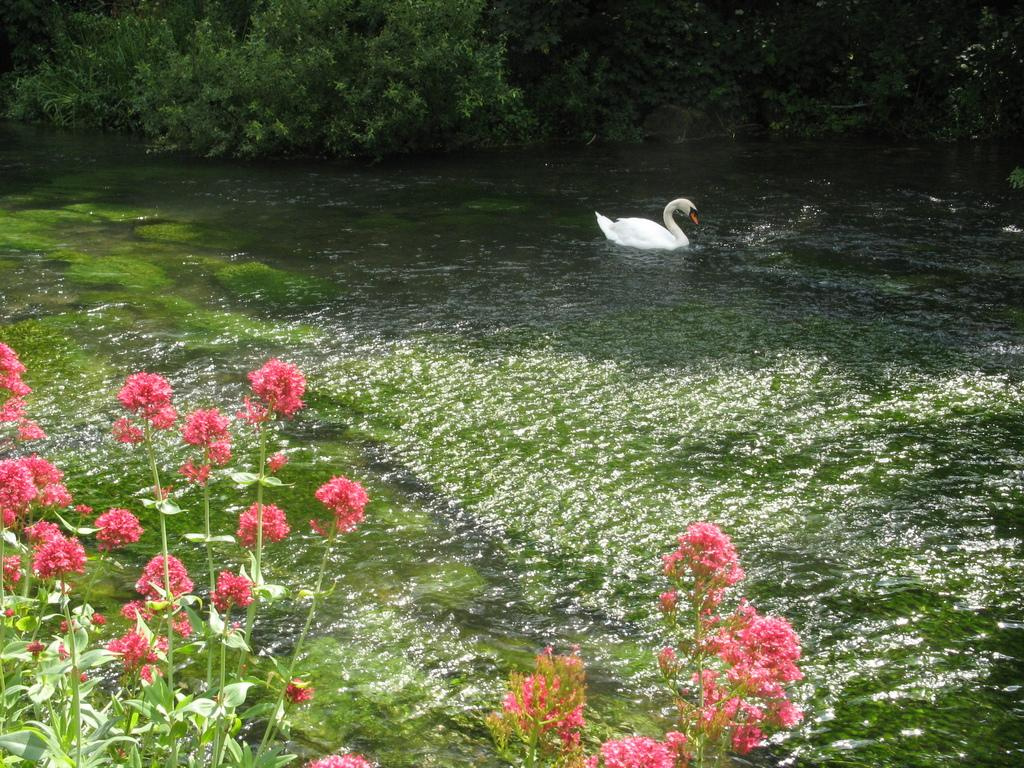What type of living organisms can be seen in the image? Plants, flowers, and a duck are visible in the image. What is the natural environment like in the image? The image features plants, flowers, water, and trees, suggesting a natural setting. Can you describe the water in the image? There is water in the image, but its specific characteristics are not mentioned in the facts. What type of bait is the duck using to catch fish in the image? There is no indication in the image that the duck is trying to catch fish, nor is there any mention of bait. Is there a kitty visible in the image? No, there is no kitty present in the image. 